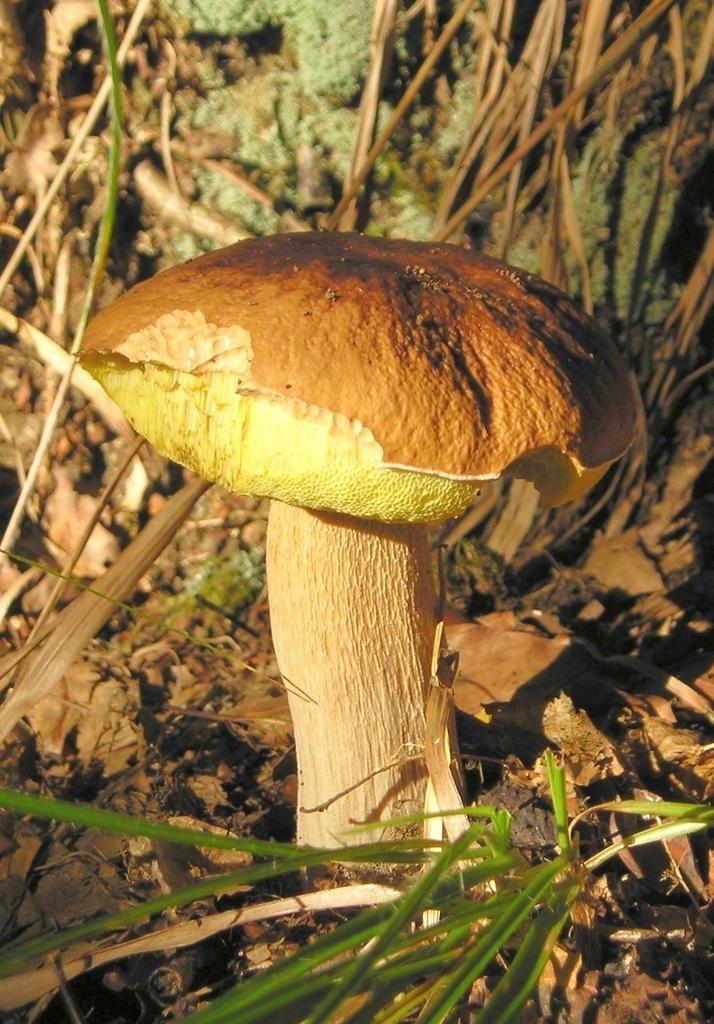How would you summarize this image in a sentence or two? In this image I can see the mushroom which is in cream, green and brown color. It is on the ground. To the side I can see the grass and some dried leaves. 